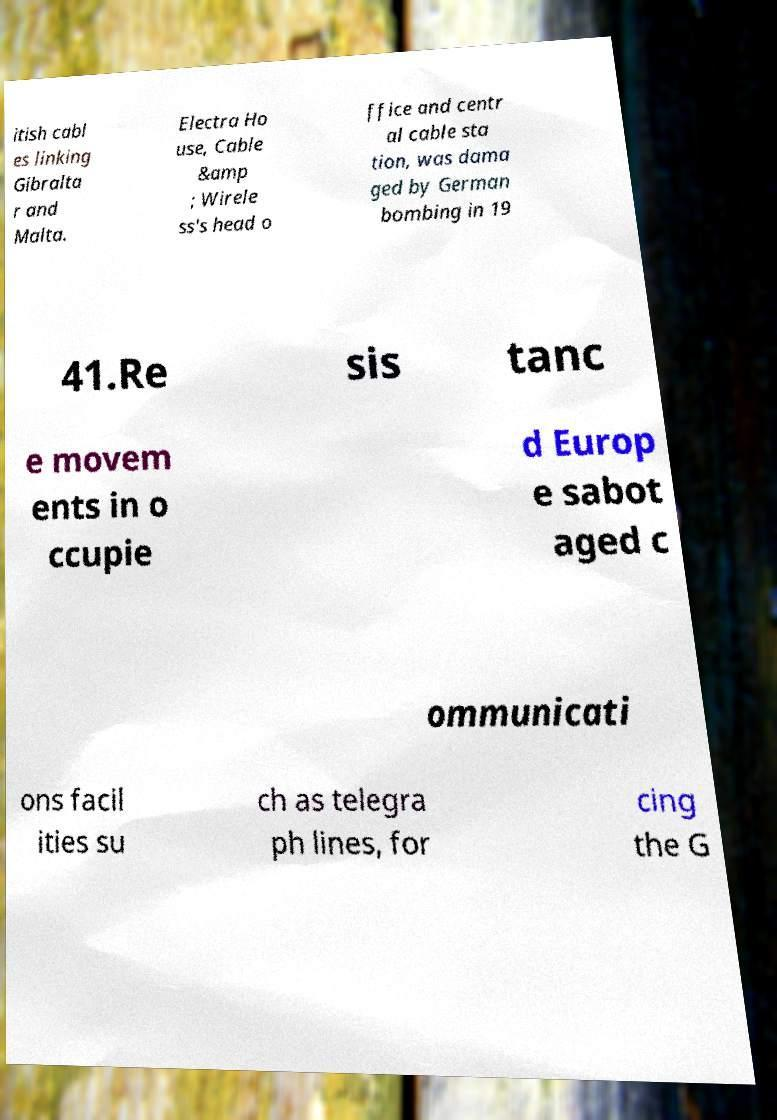What messages or text are displayed in this image? I need them in a readable, typed format. itish cabl es linking Gibralta r and Malta. Electra Ho use, Cable &amp ; Wirele ss's head o ffice and centr al cable sta tion, was dama ged by German bombing in 19 41.Re sis tanc e movem ents in o ccupie d Europ e sabot aged c ommunicati ons facil ities su ch as telegra ph lines, for cing the G 